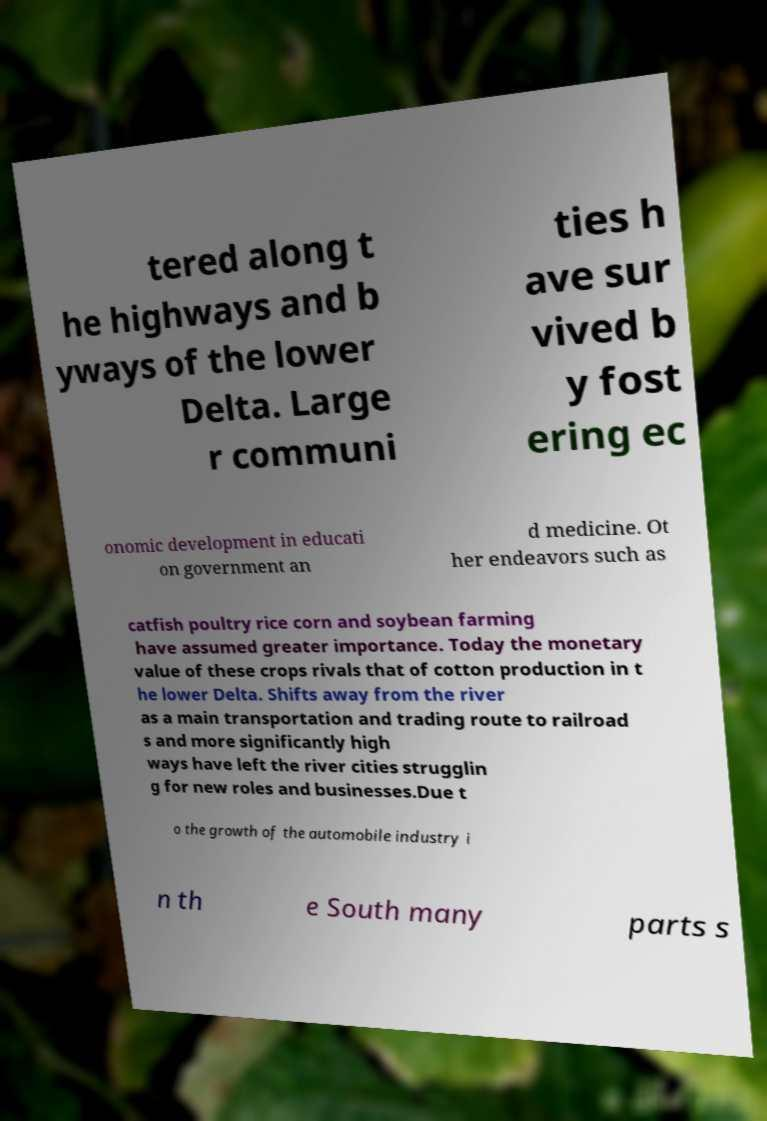I need the written content from this picture converted into text. Can you do that? tered along t he highways and b yways of the lower Delta. Large r communi ties h ave sur vived b y fost ering ec onomic development in educati on government an d medicine. Ot her endeavors such as catfish poultry rice corn and soybean farming have assumed greater importance. Today the monetary value of these crops rivals that of cotton production in t he lower Delta. Shifts away from the river as a main transportation and trading route to railroad s and more significantly high ways have left the river cities strugglin g for new roles and businesses.Due t o the growth of the automobile industry i n th e South many parts s 